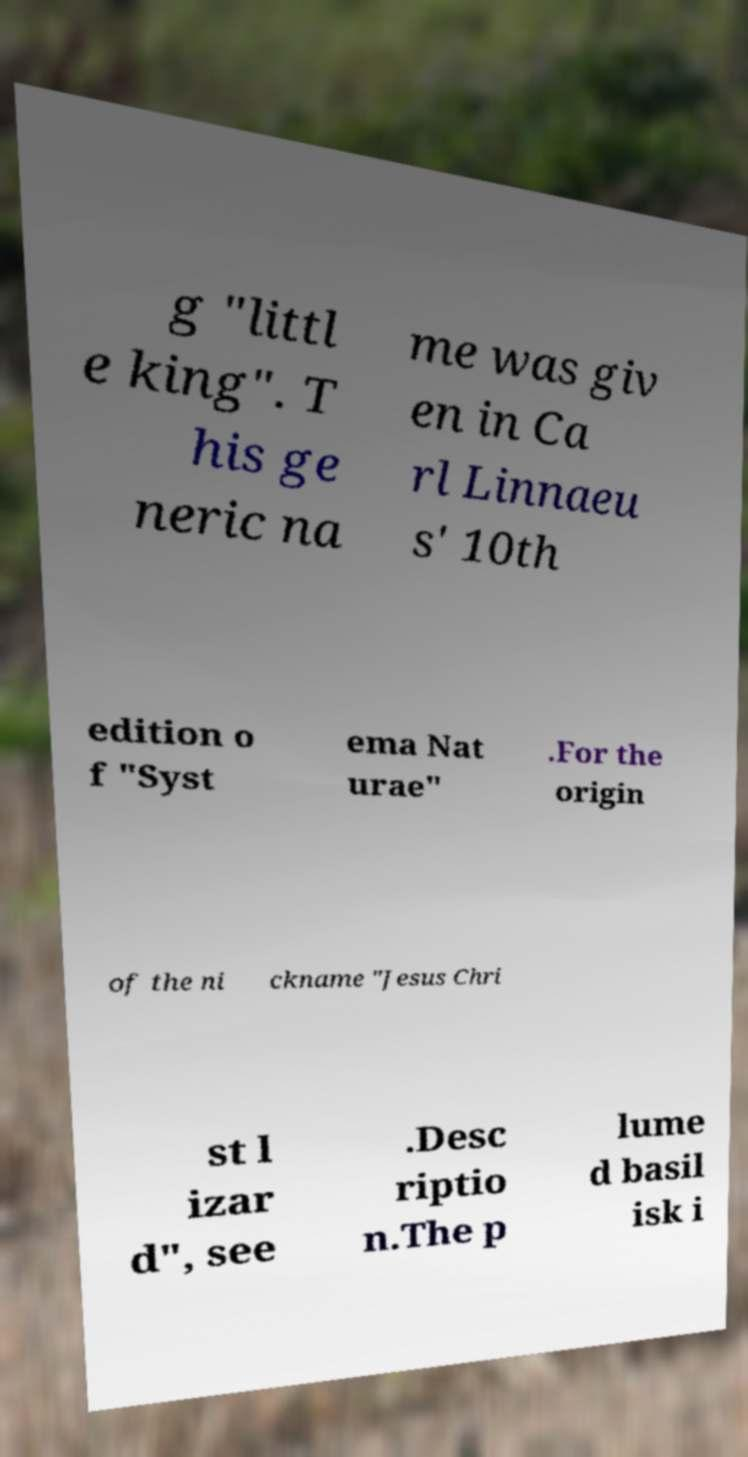There's text embedded in this image that I need extracted. Can you transcribe it verbatim? g "littl e king". T his ge neric na me was giv en in Ca rl Linnaeu s' 10th edition o f "Syst ema Nat urae" .For the origin of the ni ckname "Jesus Chri st l izar d", see .Desc riptio n.The p lume d basil isk i 